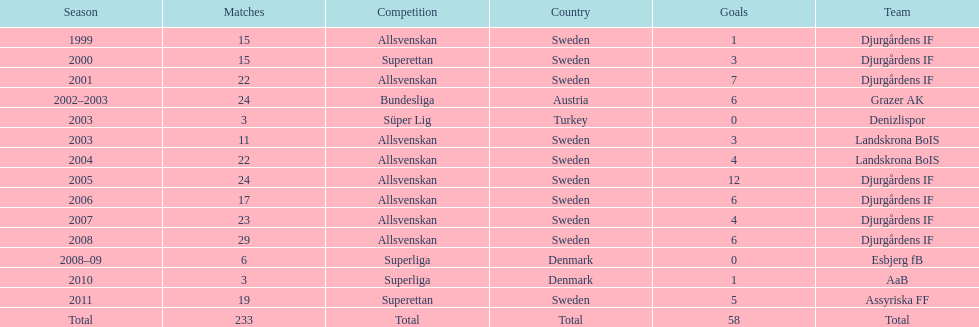What is the cumulative sum of goals jones kusi-asare has scored? 58. Give me the full table as a dictionary. {'header': ['Season', 'Matches', 'Competition', 'Country', 'Goals', 'Team'], 'rows': [['1999', '15', 'Allsvenskan', 'Sweden', '1', 'Djurgårdens IF'], ['2000', '15', 'Superettan', 'Sweden', '3', 'Djurgårdens IF'], ['2001', '22', 'Allsvenskan', 'Sweden', '7', 'Djurgårdens IF'], ['2002–2003', '24', 'Bundesliga', 'Austria', '6', 'Grazer AK'], ['2003', '3', 'Süper Lig', 'Turkey', '0', 'Denizlispor'], ['2003', '11', 'Allsvenskan', 'Sweden', '3', 'Landskrona BoIS'], ['2004', '22', 'Allsvenskan', 'Sweden', '4', 'Landskrona BoIS'], ['2005', '24', 'Allsvenskan', 'Sweden', '12', 'Djurgårdens IF'], ['2006', '17', 'Allsvenskan', 'Sweden', '6', 'Djurgårdens IF'], ['2007', '23', 'Allsvenskan', 'Sweden', '4', 'Djurgårdens IF'], ['2008', '29', 'Allsvenskan', 'Sweden', '6', 'Djurgårdens IF'], ['2008–09', '6', 'Superliga', 'Denmark', '0', 'Esbjerg fB'], ['2010', '3', 'Superliga', 'Denmark', '1', 'AaB'], ['2011', '19', 'Superettan', 'Sweden', '5', 'Assyriska FF'], ['Total', '233', 'Total', 'Total', '58', 'Total']]} 